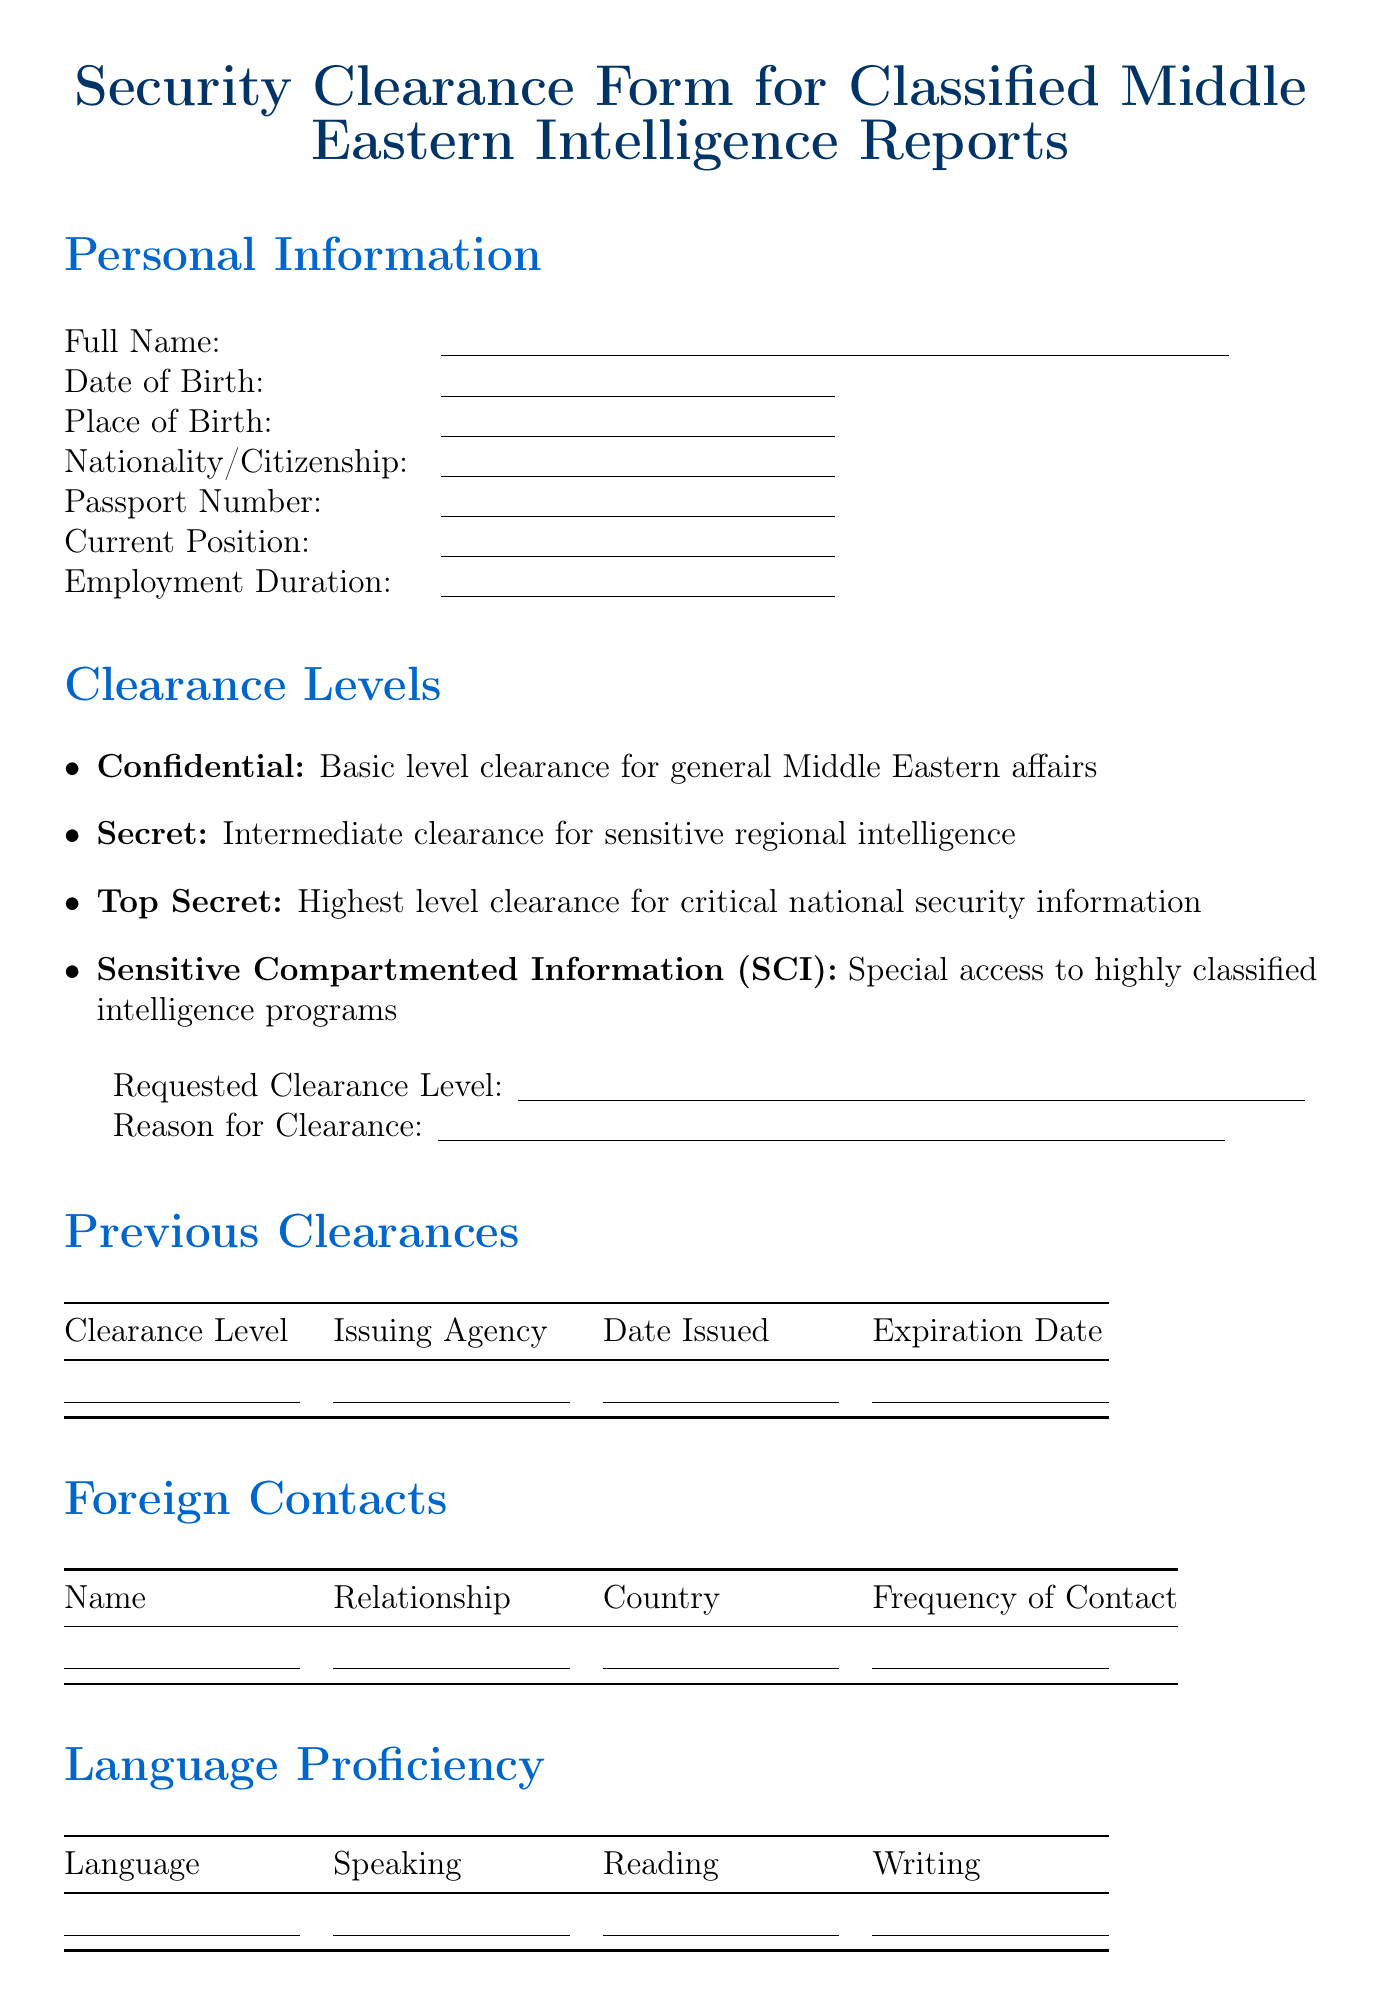What is the form title? The form title is explicitly mentioned at the top of the document, stating the purpose of the form.
Answer: Security Clearance Form for Classified Middle Eastern Intelligence Reports What level of clearance requires special access to highly classified intelligence programs? The document lists various clearance levels, including one that specifically states the nature of access granted by that level.
Answer: Sensitive Compartmented Information (SCI) What is the required information for foreign contacts? The document asks for details about individuals with foreign ties, including their name, relationship, country, and frequency of contact.
Answer: Name, Relationship, Country, Frequency of Contact What is the declaration statement? The declaration statement is explicitly provided in the form, highlighting the responsibilities of the individual filling it out.
Answer: I hereby declare that the information provided in this form is true and complete to the best of my knowledge. I understand that any false statement or omission may result in the denial or revocation of my security clearance What is the purpose of the "Official Use Only" section? The section is designed for internal processing and contains fields specific to the background check and clearance decision.
Answer: Background Check Status, Polygraph Test Required, Interview Date, etc 